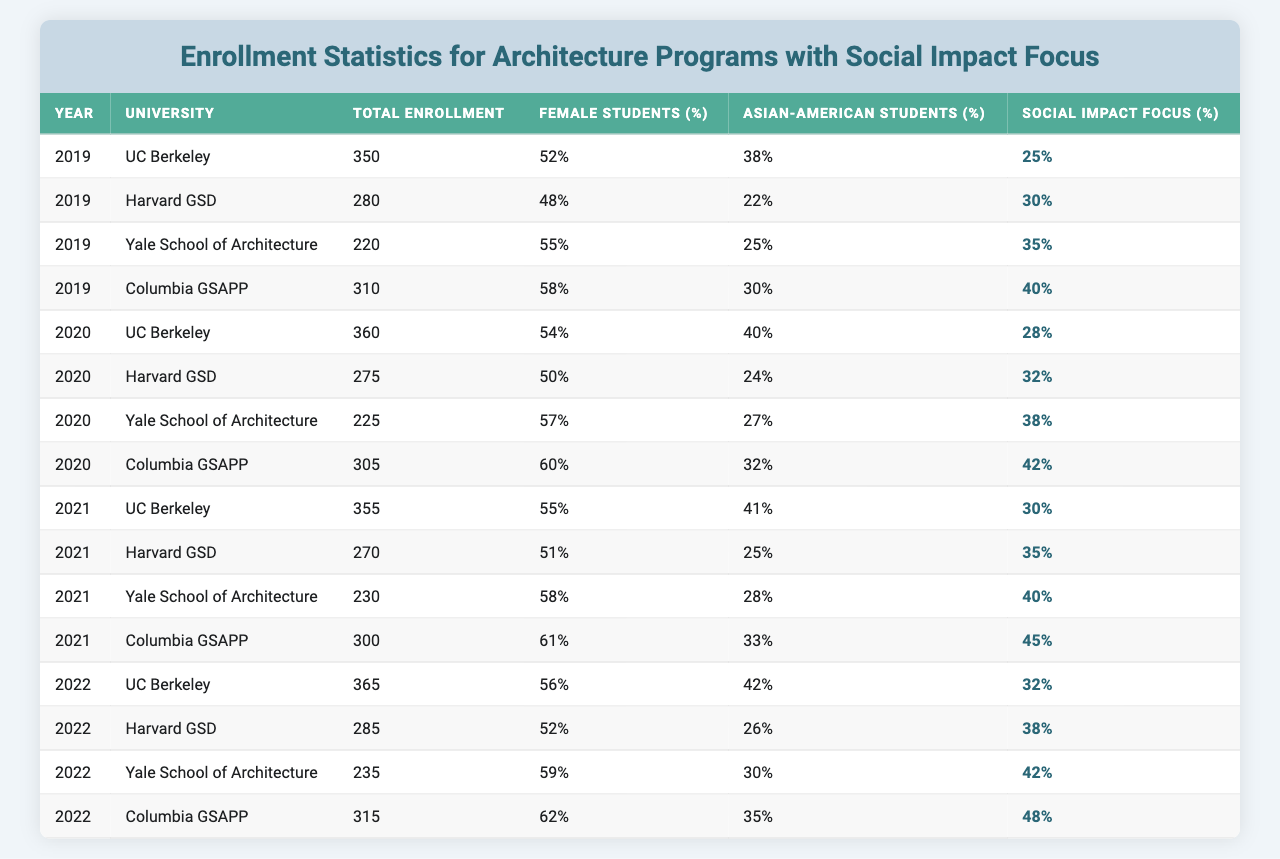What university had the highest total enrollment in 2021? The total enrollment for each university in 2021 can be found in the provided data. UC Berkeley had 355 students, Harvard GSD had 270, Yale School of Architecture had 230, and Columbia GSAPP had 300. Comparing these numbers, UC Berkeley had the highest enrollment at 355.
Answer: UC Berkeley What percentage of female students enrolled at Yale School of Architecture in 2020? The data shows that Yale School of Architecture had 57% female students in 2020. This value can be found directly in the table under the column for female students for the specified year and university.
Answer: 57% What was the average percentage of Asian-American students in 2019 across all the universities? To calculate the average percentage of Asian-American students in 2019, we sum the percentages for each university: (38 + 22 + 25 + 30) = 115. Then divide by the number of universities, which is 4: 115 / 4 = 28.75.
Answer: 28.75 Did the percentage of students with a social impact focus increase from 2019 to 2022 at Columbia GSAPP? To answer this, we check the social impact focus percentage for Columbia GSAPP in both years: in 2019 it was 40%, and in 2022 it increased to 48%. Since 48% is greater than 40%, the percentage did increase.
Answer: Yes Which university had the highest percentage of female students in 2022? The female student percentages for 2022 are as follows: UC Berkeley 56%, Harvard GSD 52%, Yale School of Architecture 59%, and Columbia GSAPP 62%. Comparing these values, Columbia GSAPP had the highest percentage at 62%.
Answer: Columbia GSAPP What is the total enrollment of all universities combined in 2020? To find the total enrollment for all universities in 2020, we add the enrollments: 360 (UC Berkeley) + 275 (Harvard GSD) + 225 (Yale School of Architecture) + 305 (Columbia GSAPP) = 1165.
Answer: 1165 Was there a decrease in total enrollment at Harvard GSD from 2019 to 2021? The total enrollments for Harvard GSD are: 280 in 2019, 275 in 2020, and 270 in 2021. The numbers are decreasing each year, indicating a drop in enrollment.
Answer: Yes What university had the lowest percentage of social impact focus in 2020? In 2020, the social impact focus percentages were: UC Berkeley 28%, Harvard GSD 32%, Yale School of Architecture 38%, and Columbia GSAPP 42%. UC Berkeley had the lowest percentage at 28%.
Answer: UC Berkeley What was the difference in total enrollment between 2021 and 2022 for Yale School of Architecture? Yale School of Architecture had 230 students in 2021 and 235 in 2022. The difference is calculated by subtracting the two values: 235 - 230 = 5.
Answer: 5 Which year saw the highest percentage of Asian-American students at UC Berkeley? The percentages for Asian-American students at UC Berkeley across the years are: 38% in 2019, 40% in 2020, 41% in 2021, and 42% in 2022. The highest percentage is 42%, observed in 2022.
Answer: 2022 What is the trend of female student percentages at Columbia GSAPP from 2019 to 2022? The female student percentages at Columbia GSAPP are: 58% in 2019, 60% in 2020, 61% in 2021, and 62% in 2022. The data shows an increasing trend each year.
Answer: Increasing 